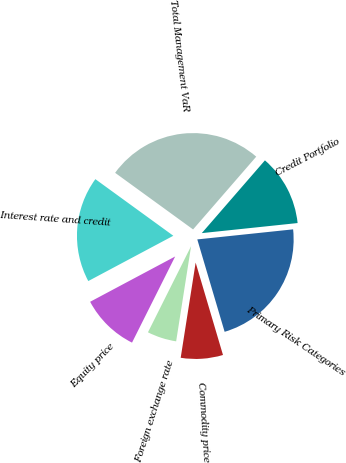Convert chart to OTSL. <chart><loc_0><loc_0><loc_500><loc_500><pie_chart><fcel>Interest rate and credit<fcel>Equity price<fcel>Foreign exchange rate<fcel>Commodity price<fcel>Primary Risk Categories<fcel>Credit Portfolio<fcel>Total Management VaR<nl><fcel>17.79%<fcel>9.82%<fcel>4.91%<fcel>7.06%<fcel>22.09%<fcel>11.96%<fcel>26.38%<nl></chart> 